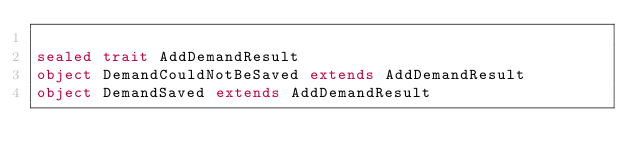Convert code to text. <code><loc_0><loc_0><loc_500><loc_500><_Scala_>
sealed trait AddDemandResult
object DemandCouldNotBeSaved extends AddDemandResult
object DemandSaved extends AddDemandResult


</code> 